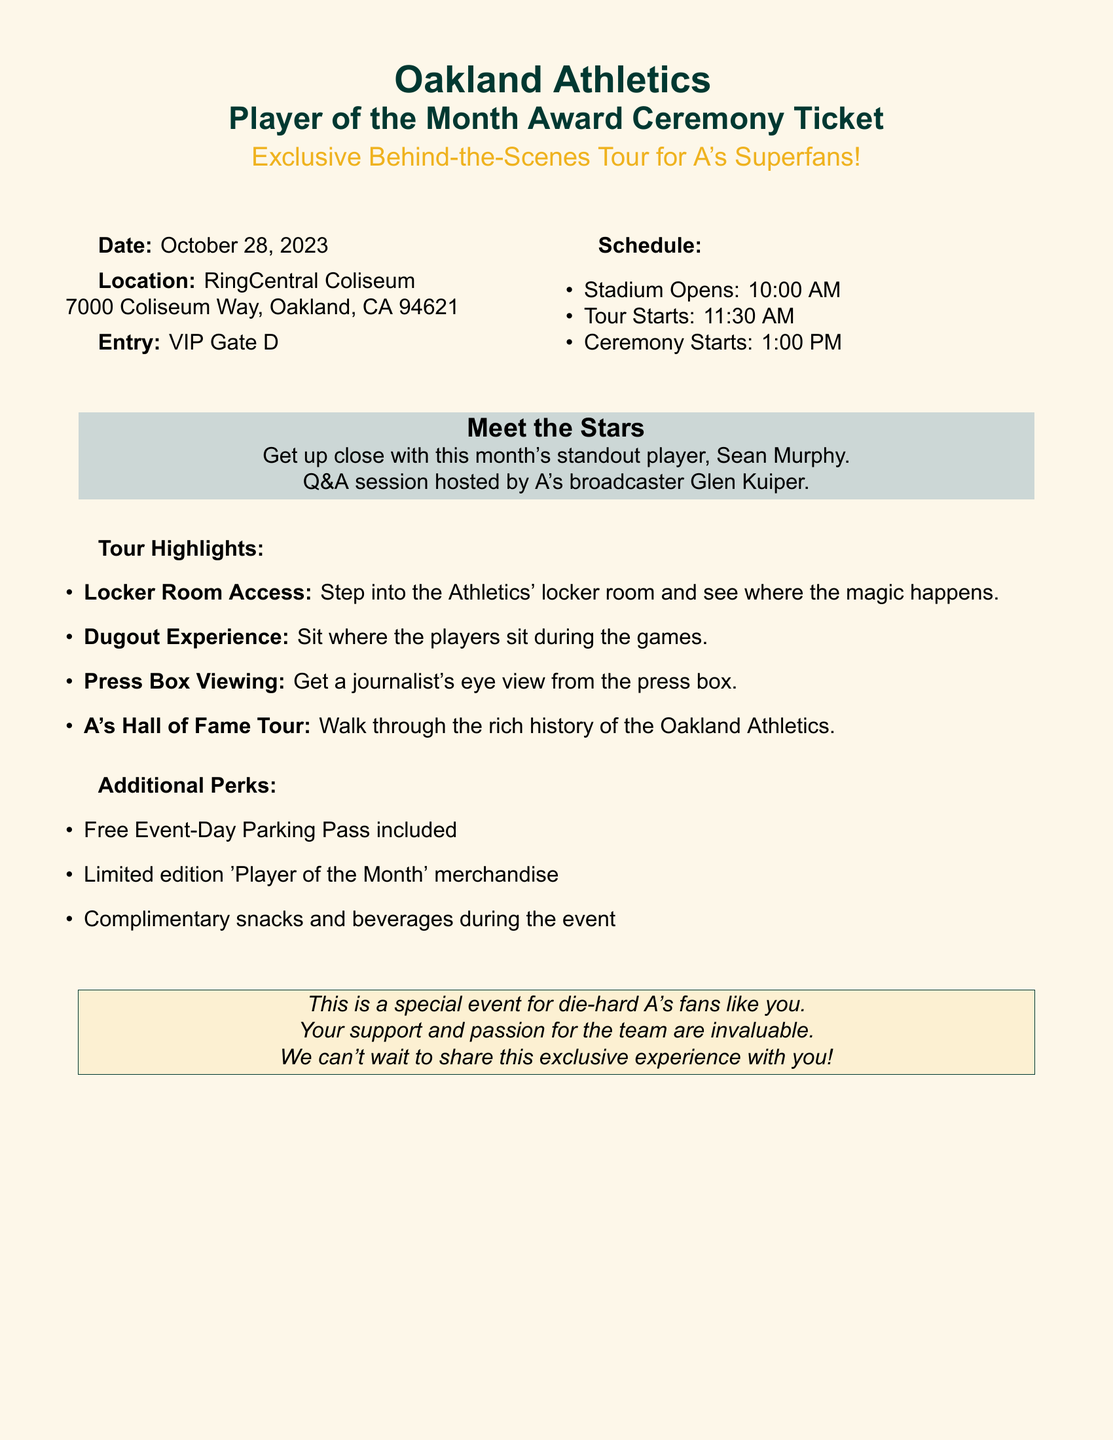What is the date of the ceremony? The date of the ceremony is mentioned in the document as October 28, 2023.
Answer: October 28, 2023 What is the location of the event? The document specifies the location of the event as RingCentral Coliseum, which is in Oakland, CA.
Answer: RingCentral Coliseum Who is the standout player for the month? The standout player mentioned in the document is Sean Murphy.
Answer: Sean Murphy What time does the tour start? The document indicates that the tour starts at 11:30 AM.
Answer: 11:30 AM What special access do attendees have during the tour? The document lists specific highlights, including locker room access, which is a unique feature of the tour.
Answer: Locker Room Access What items are included in the additional perks? The document highlights that limited edition 'Player of the Month' merchandise is one of the perks included for attendees.
Answer: Limited edition 'Player of the Month' merchandise Who will host the Q&A session? The host for the Q&A session is mentioned in the document as A's broadcaster Glen Kuiper.
Answer: Glen Kuiper What is the entry point for the event? The document specifies that the entry is through VIP Gate D.
Answer: VIP Gate D What time does the stadium open? According to the document, the stadium opens at 10:00 AM.
Answer: 10:00 AM 